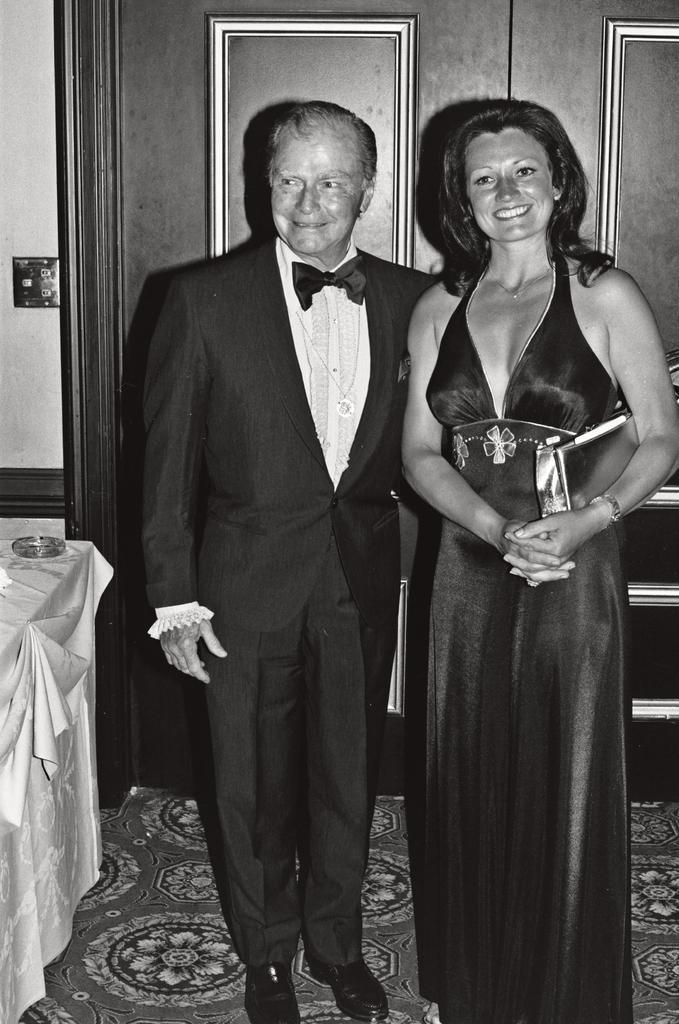Describe this image in one or two sentences. This is a black and white image where we can see a person wearing blazer and a woman wearing dress are standing here and smiling. Here I can see a table on the left side of the image and in the background, I can see the doors. 